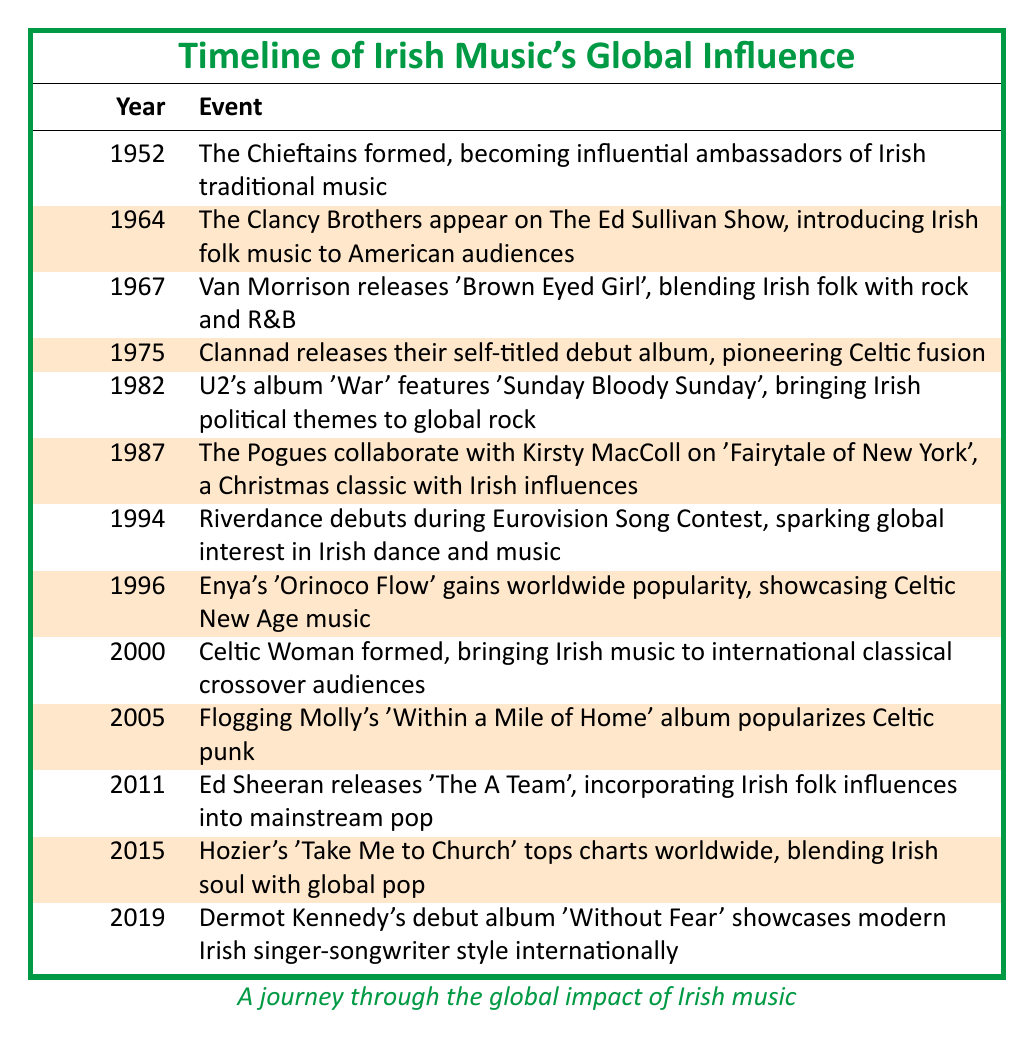What year did The Chieftains form? The table lists the first event, which states that The Chieftains formed in 1952.
Answer: 1952 Which artist released "Brown Eyed Girl"? Referring to the event in 1967, Van Morrison is noted as the artist who released "Brown Eyed Girl."
Answer: Van Morrison What is the significance of 1994 in this timeline? The table indicates that in 1994, Riverdance debuted during the Eurovision Song Contest, marking a key moment in promoting Irish dance and music globally.
Answer: Riverdance debuted How many events mention collaborations or influences with other artists? By reviewing the timeline, the events for 1987 (The Pogues with Kirsty MacColl) and 2011 (Ed Sheeran incorporating Irish influences) both mention collaborations or influences with other artists. Counting those gives us a total of 2 events.
Answer: 2 What year saw the debut of Celtic Woman? The table states that Celtic Woman formed in the year 2000, highlighting a significant event in the promotion of Irish music to international audiences.
Answer: 2000 Did U2 incorporate political themes in their music? According to the timeline for the year 1982, U2's album "War" features the song "Sunday Bloody Sunday," which is noted for addressing Irish political themes, confirming that they did incorporate such themes.
Answer: Yes Which event occurred closest to the launch of Enya's "Orinoco Flow"? By examining the years in the table, Enya's "Orinoco Flow" was released in 1996, and the event just before that is Riverdance in 1994. Therefore, Riverdance is the event closest to Enya's release.
Answer: Riverdance in 1994 Determine the time gap between the formation of The Chieftains and the release of Ed Sheeran's "The A Team." The Chieftains formed in 1952, and Ed Sheeran released "The A Team" in 2011. Calculating the difference between these two years (2011 - 1952) gives a gap of 59 years.
Answer: 59 years What Irish music influence saw global popularity in 2015? The table notes that in 2015, Hozier's song "Take Me to Church" topped charts worldwide, showcasing the influence of Irish music in global pop.
Answer: Hozier's "Take Me to Church" 